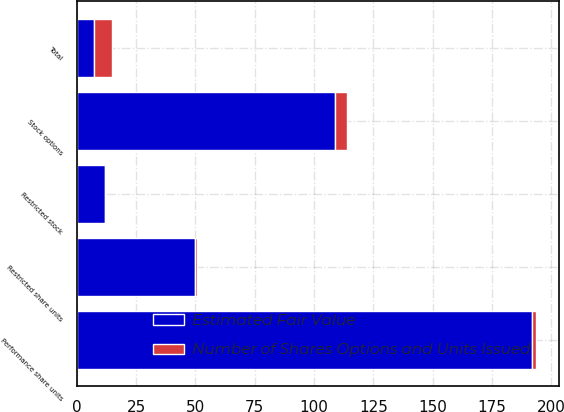Convert chart. <chart><loc_0><loc_0><loc_500><loc_500><stacked_bar_chart><ecel><fcel>Performance share units<fcel>Stock options<fcel>Restricted share units<fcel>Restricted stock<fcel>Total<nl><fcel>Number of Shares Options and Units Issued<fcel>1.6<fcel>4.8<fcel>0.8<fcel>0.2<fcel>7.4<nl><fcel>Estimated Fair Value<fcel>192<fcel>109<fcel>50<fcel>12<fcel>7.4<nl></chart> 